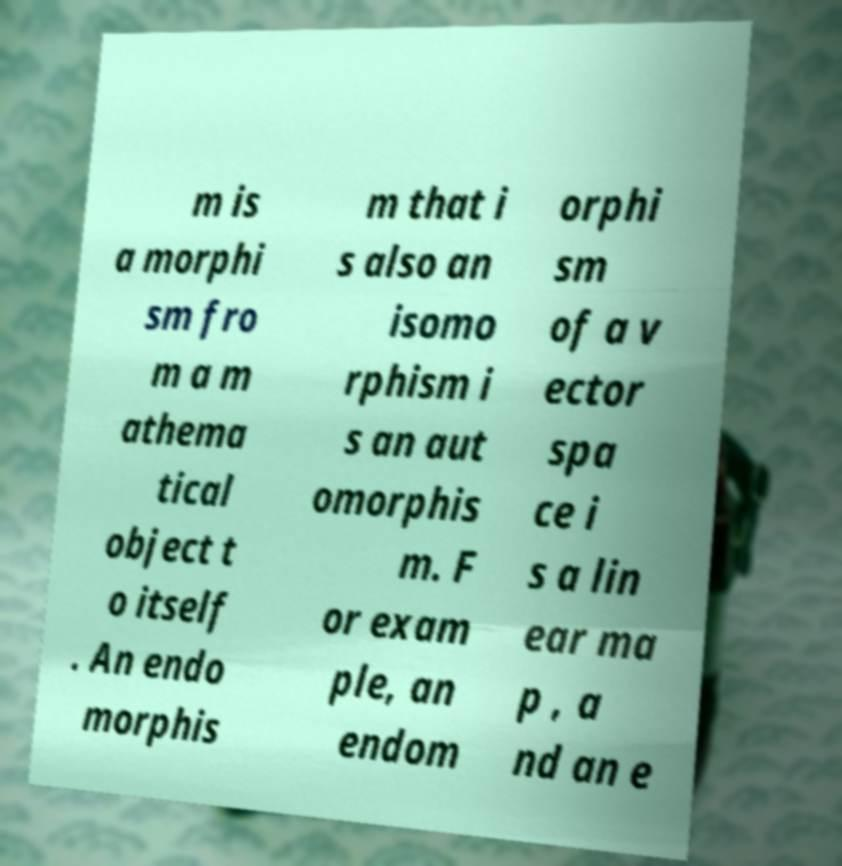What messages or text are displayed in this image? I need them in a readable, typed format. m is a morphi sm fro m a m athema tical object t o itself . An endo morphis m that i s also an isomo rphism i s an aut omorphis m. F or exam ple, an endom orphi sm of a v ector spa ce i s a lin ear ma p , a nd an e 